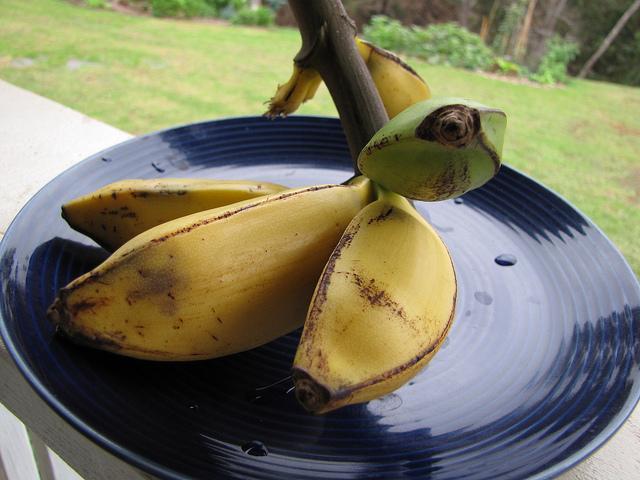How many dining tables are in the photo?
Give a very brief answer. 1. How many bananas can you see?
Give a very brief answer. 5. 